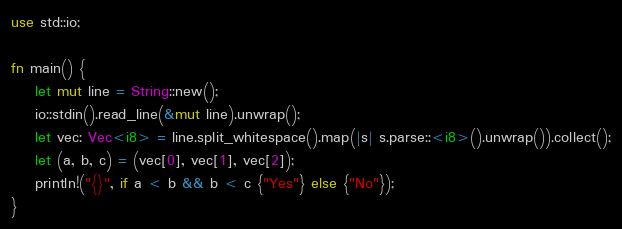<code> <loc_0><loc_0><loc_500><loc_500><_Rust_>use std::io;

fn main() {
    let mut line = String::new();
    io::stdin().read_line(&mut line).unwrap();
    let vec: Vec<i8> = line.split_whitespace().map(|s| s.parse::<i8>().unwrap()).collect();
    let (a, b, c) = (vec[0], vec[1], vec[2]);
    println!("{}", if a < b && b < c {"Yes"} else {"No"});
}
</code> 